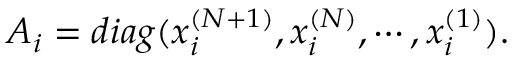<formula> <loc_0><loc_0><loc_500><loc_500>A _ { i } = d i a g ( x _ { i } ^ { ( N + 1 ) } , x _ { i } ^ { ( N ) } , \cdots , x _ { i } ^ { ( 1 ) } ) .</formula> 